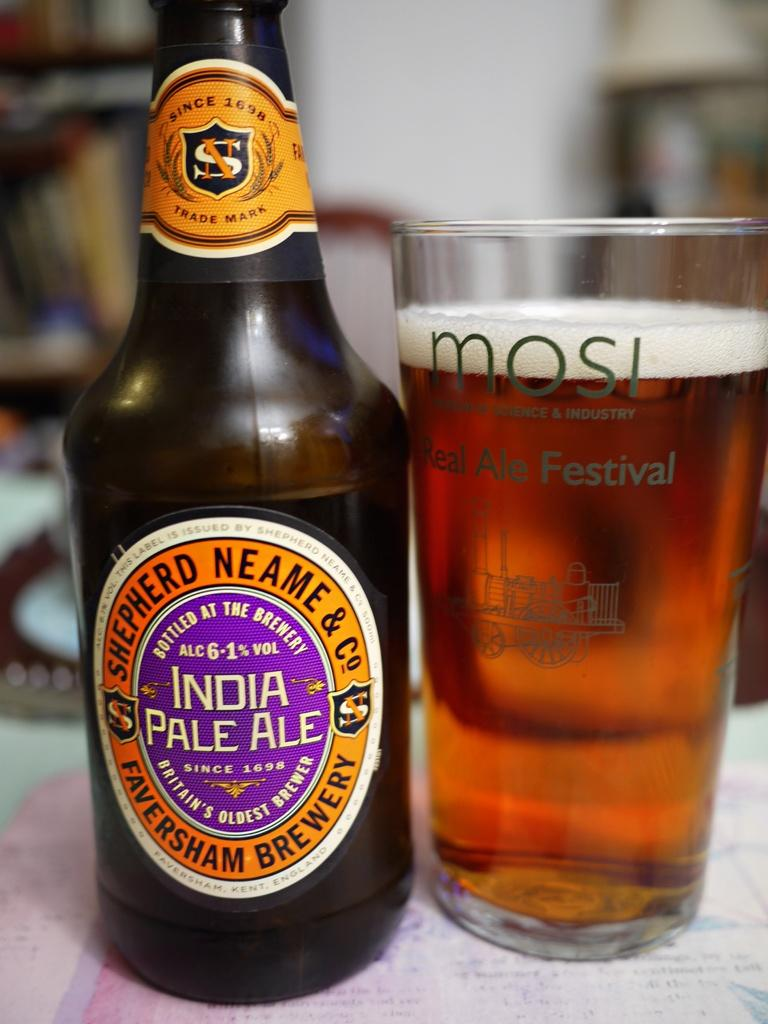<image>
Write a terse but informative summary of the picture. A bottle of Shepherd Neame India Pale Ale next to a glass of what is probably the same 